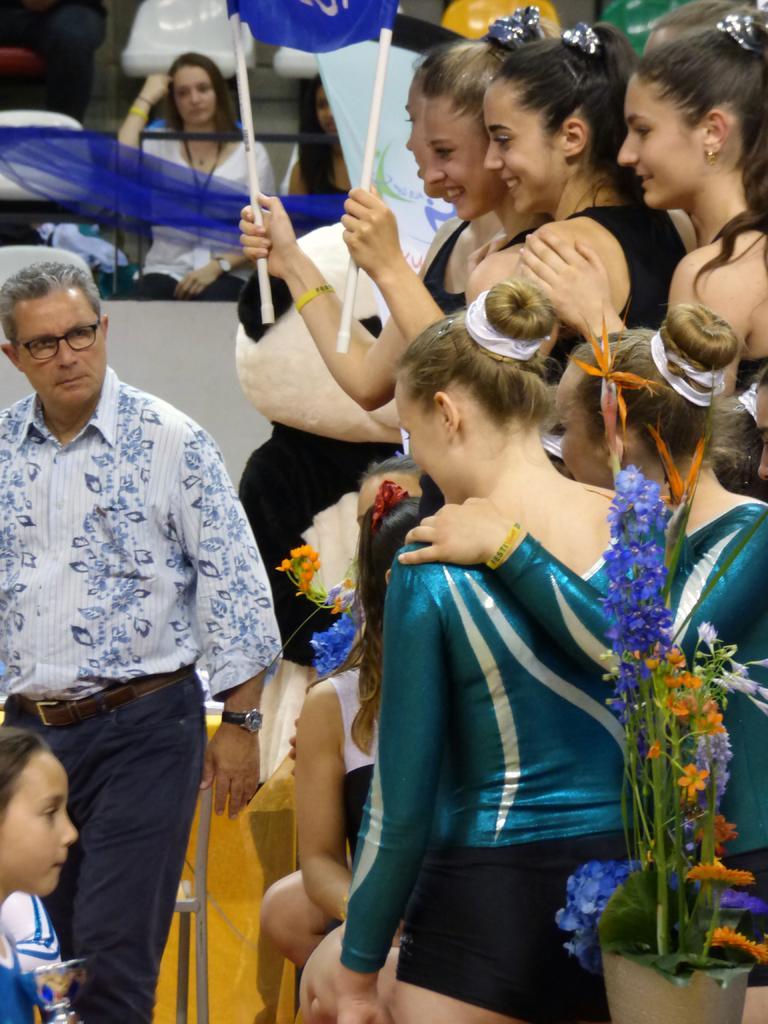How would you summarize this image in a sentence or two? There is a group of persons standing as we can see in the middle of this image. There are some flowers in a pot at the bottom left side of this image. There is a fencing on the top left side of this image, and there is one woman sitting beside to this fencing. 